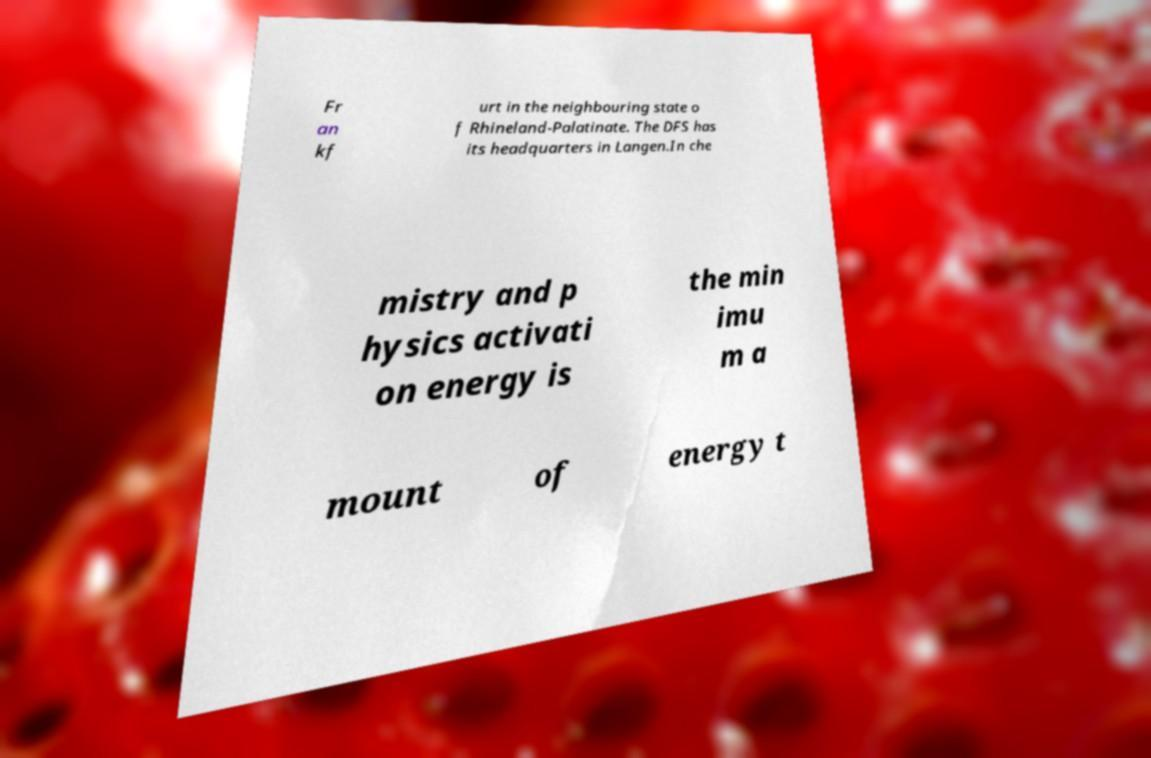Can you read and provide the text displayed in the image?This photo seems to have some interesting text. Can you extract and type it out for me? Fr an kf urt in the neighbouring state o f Rhineland-Palatinate. The DFS has its headquarters in Langen.In che mistry and p hysics activati on energy is the min imu m a mount of energy t 